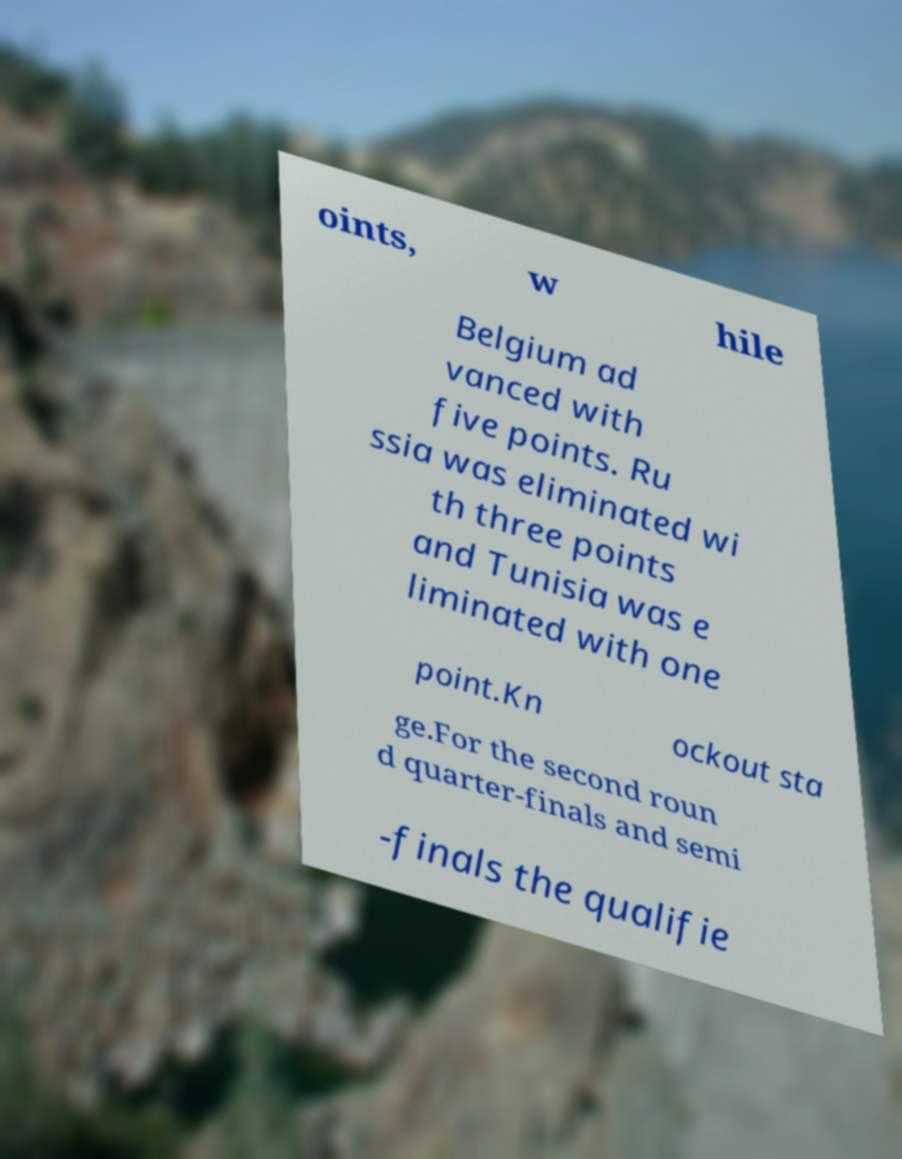Can you read and provide the text displayed in the image?This photo seems to have some interesting text. Can you extract and type it out for me? oints, w hile Belgium ad vanced with five points. Ru ssia was eliminated wi th three points and Tunisia was e liminated with one point.Kn ockout sta ge.For the second roun d quarter-finals and semi -finals the qualifie 